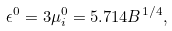<formula> <loc_0><loc_0><loc_500><loc_500>\epsilon ^ { 0 } = 3 \mu _ { i } ^ { 0 } = 5 . 7 1 4 B ^ { 1 / 4 } ,</formula> 